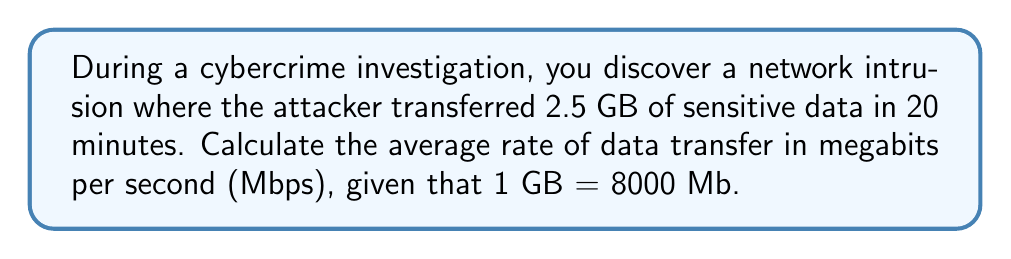Provide a solution to this math problem. To solve this problem, we need to follow these steps:

1. Convert the data size from GB to Mb:
   $2.5 \text{ GB} = 2.5 \times 8000 \text{ Mb} = 20000 \text{ Mb}$

2. Convert the time from minutes to seconds:
   $20 \text{ minutes} = 20 \times 60 \text{ seconds} = 1200 \text{ seconds}$

3. Calculate the rate of data transfer using the formula:
   $$\text{Rate} = \frac{\text{Data size}}{\text{Time}}$$

   Substituting our values:
   $$\text{Rate} = \frac{20000 \text{ Mb}}{1200 \text{ s}} = \frac{50}{3} \text{ Mbps}$$

4. Simplify the fraction:
   $$\frac{50}{3} \approx 16.67 \text{ Mbps}$$

Therefore, the average rate of data transfer during the network intrusion was approximately 16.67 Mbps.
Answer: 16.67 Mbps 